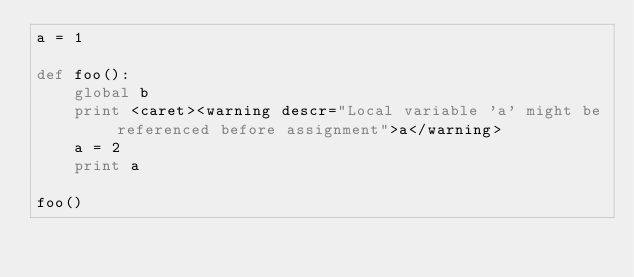<code> <loc_0><loc_0><loc_500><loc_500><_Python_>a = 1

def foo():
    global b
    print <caret><warning descr="Local variable 'a' might be referenced before assignment">a</warning>
    a = 2
    print a

foo()
</code> 